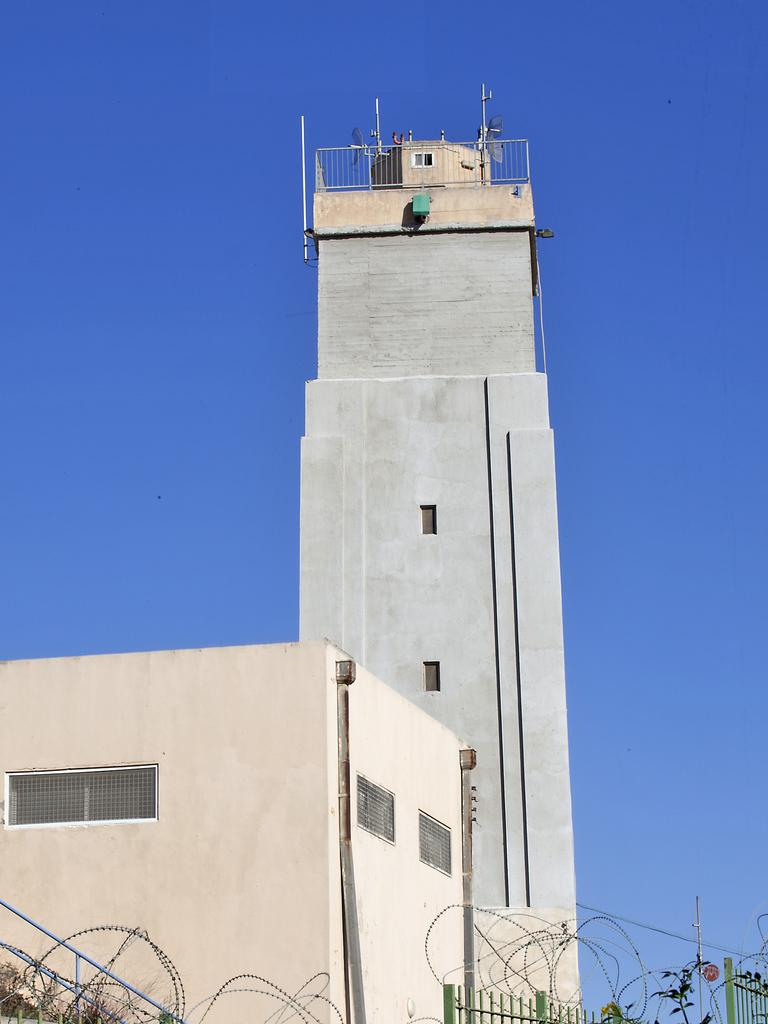What type of structures can be seen in the image? There are buildings in the image. What else is present in the image besides the buildings? There is fencing in the image. How many eyes can be seen on the buildings in the image? Buildings do not have eyes, so this question cannot be answered definitively from the image. What type of vehicles are parked near the buildings in the image? There is no information about vehicles in the image, as it only mentions buildings and fencing. 